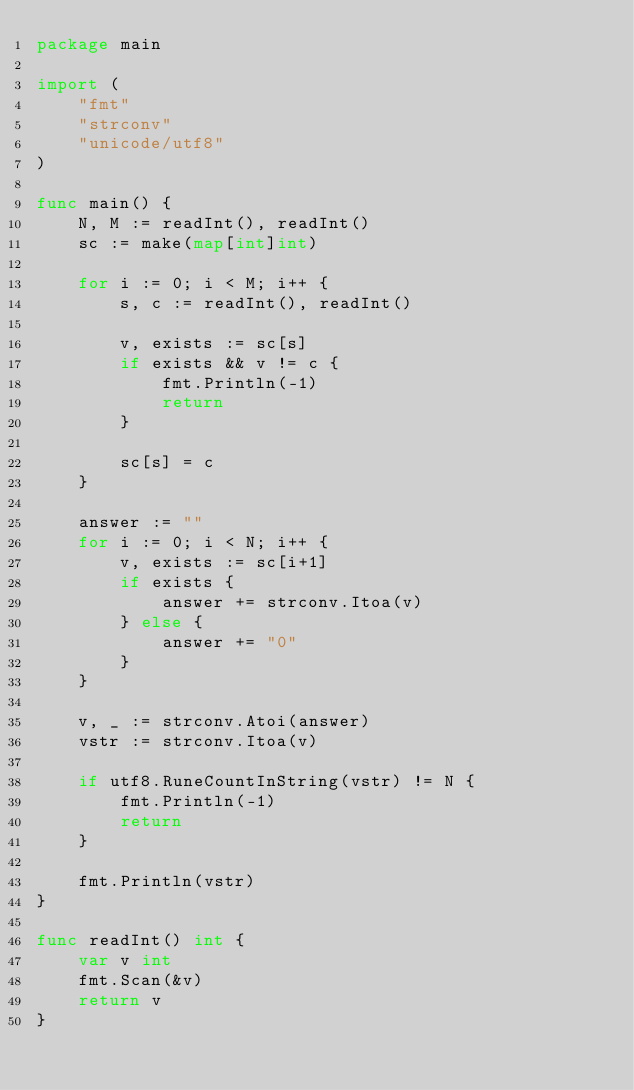<code> <loc_0><loc_0><loc_500><loc_500><_Go_>package main

import (
	"fmt"
	"strconv"
	"unicode/utf8"
)

func main() {
	N, M := readInt(), readInt()
	sc := make(map[int]int)

	for i := 0; i < M; i++ {
		s, c := readInt(), readInt()

		v, exists := sc[s]
		if exists && v != c {
			fmt.Println(-1)
			return
		}

		sc[s] = c
	}

	answer := ""
	for i := 0; i < N; i++ {
		v, exists := sc[i+1]
		if exists {
			answer += strconv.Itoa(v)
		} else {
			answer += "0"
		}
	}

	v, _ := strconv.Atoi(answer)
	vstr := strconv.Itoa(v)

	if utf8.RuneCountInString(vstr) != N {
		fmt.Println(-1)
		return
	}

	fmt.Println(vstr)
}

func readInt() int {
	var v int
	fmt.Scan(&v)
	return v
}
</code> 